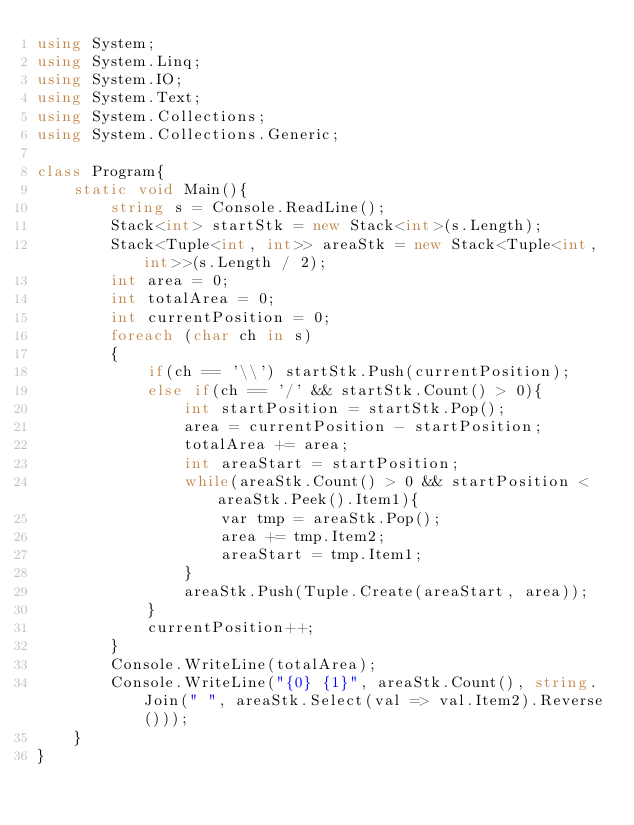Convert code to text. <code><loc_0><loc_0><loc_500><loc_500><_C#_>using System;
using System.Linq;
using System.IO;
using System.Text;
using System.Collections;
using System.Collections.Generic;
 
class Program{
    static void Main(){
        string s = Console.ReadLine();
        Stack<int> startStk = new Stack<int>(s.Length);
        Stack<Tuple<int, int>> areaStk = new Stack<Tuple<int, int>>(s.Length / 2);
        int area = 0;
        int totalArea = 0;
        int currentPosition = 0;
        foreach (char ch in s)
        {
            if(ch == '\\') startStk.Push(currentPosition);
            else if(ch == '/' && startStk.Count() > 0){
                int startPosition = startStk.Pop();
                area = currentPosition - startPosition;
                totalArea += area;
                int areaStart = startPosition;
                while(areaStk.Count() > 0 && startPosition < areaStk.Peek().Item1){
                    var tmp = areaStk.Pop();
                    area += tmp.Item2;
                    areaStart = tmp.Item1;
                }
                areaStk.Push(Tuple.Create(areaStart, area));
            }
            currentPosition++;
        }
        Console.WriteLine(totalArea);
        Console.WriteLine("{0} {1}", areaStk.Count(), string.Join(" ", areaStk.Select(val => val.Item2).Reverse()));
    }
}</code> 